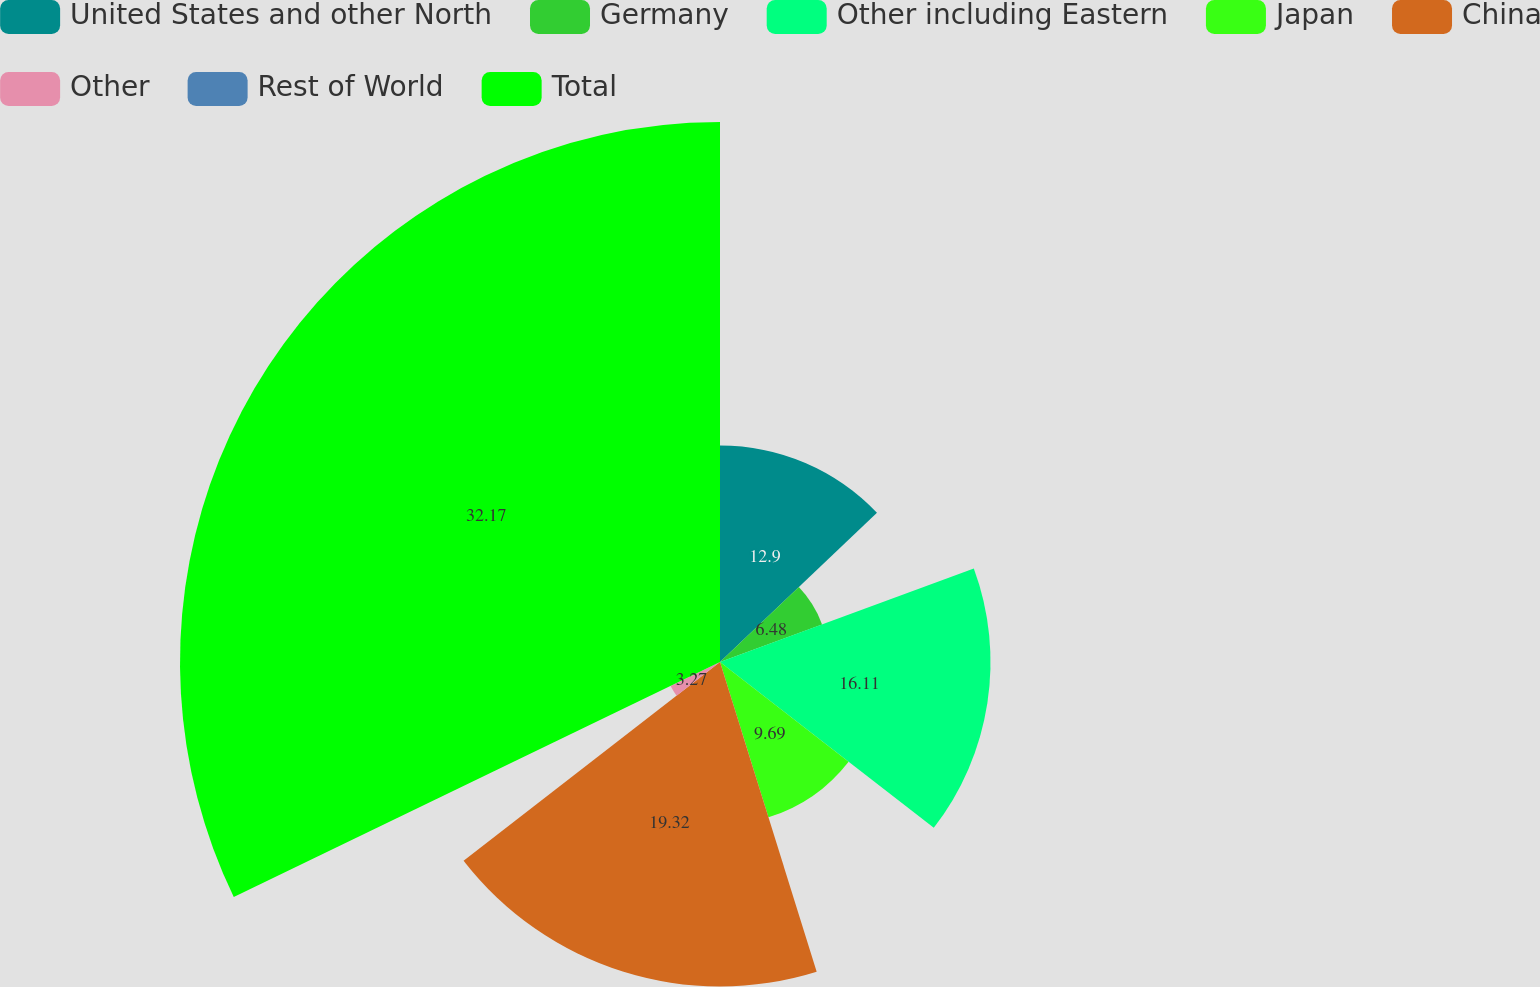<chart> <loc_0><loc_0><loc_500><loc_500><pie_chart><fcel>United States and other North<fcel>Germany<fcel>Other including Eastern<fcel>Japan<fcel>China<fcel>Other<fcel>Rest of World<fcel>Total<nl><fcel>12.9%<fcel>6.48%<fcel>16.11%<fcel>9.69%<fcel>19.32%<fcel>3.27%<fcel>0.06%<fcel>32.16%<nl></chart> 